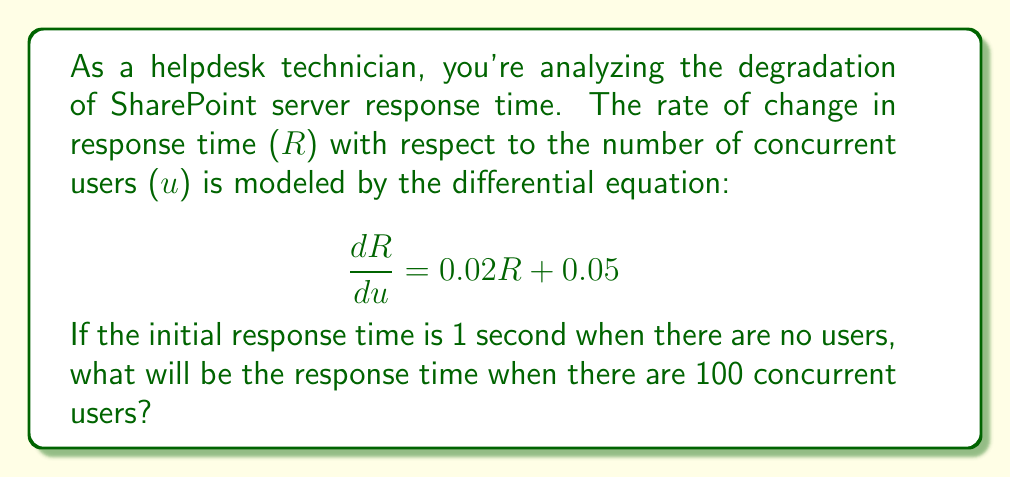Can you answer this question? To solve this problem, we need to use the method for solving first-order linear differential equations. The general form of such equations is:

$$\frac{dy}{dx} + P(x)y = Q(x)$$

In our case:
- $y = R$ (response time)
- $x = u$ (number of users)
- $P(u) = -0.02$ (note the sign change to match the standard form)
- $Q(u) = 0.05$

The general solution for this type of equation is:

$$y = e^{-\int P(x)dx} \left( \int Q(x)e^{\int P(x)dx}dx + C \right)$$

Step 1: Calculate $\int P(u)du$
$$\int P(u)du = \int -0.02du = -0.02u$$

Step 2: Calculate $e^{\int P(u)du}$
$$e^{\int P(u)du} = e^{-0.02u}$$

Step 3: Calculate $Q(u)e^{\int P(u)du}$
$$Q(u)e^{\int P(u)du} = 0.05e^{-0.02u}$$

Step 4: Integrate $Q(u)e^{\int P(u)du}$
$$\int Q(u)e^{\int P(u)du}du = \int 0.05e^{-0.02u}du = -2.5e^{-0.02u} + C_1$$

Step 5: Multiply by $e^{-\int P(u)du}$ to get the general solution
$$R = e^{0.02u}(-2.5e^{-0.02u} + C_1) = -2.5 + C_1e^{0.02u}$$

Step 6: Apply the initial condition R(0) = 1 to find C1
$$1 = -2.5 + C_1$$
$$C_1 = 3.5$$

Step 7: Write the particular solution
$$R = -2.5 + 3.5e^{0.02u}$$

Step 8: Calculate R when u = 100
$$R(100) = -2.5 + 3.5e^{0.02(100)} = -2.5 + 3.5e^2 \approx 24.13$$
Answer: The response time when there are 100 concurrent users will be approximately 24.13 seconds. 